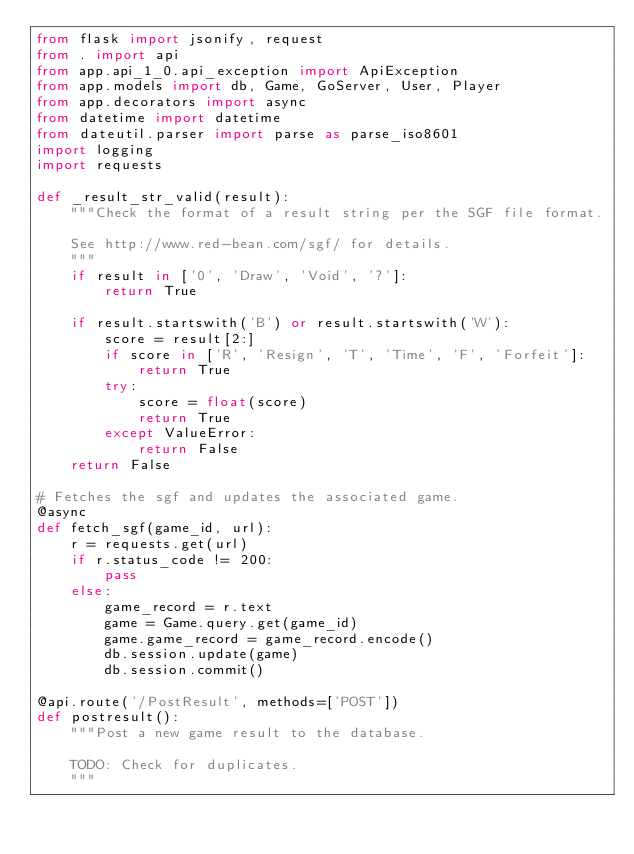<code> <loc_0><loc_0><loc_500><loc_500><_Python_>from flask import jsonify, request
from . import api
from app.api_1_0.api_exception import ApiException
from app.models import db, Game, GoServer, User, Player
from app.decorators import async
from datetime import datetime
from dateutil.parser import parse as parse_iso8601
import logging
import requests

def _result_str_valid(result):
    """Check the format of a result string per the SGF file format.

    See http://www.red-bean.com/sgf/ for details.
    """
    if result in ['0', 'Draw', 'Void', '?']:
        return True

    if result.startswith('B') or result.startswith('W'):
        score = result[2:]
        if score in ['R', 'Resign', 'T', 'Time', 'F', 'Forfeit']:
            return True
        try:
            score = float(score)
            return True
        except ValueError:
            return False
    return False

# Fetches the sgf and updates the associated game.
@async
def fetch_sgf(game_id, url):
    r = requests.get(url)
    if r.status_code != 200:
        pass
    else:
        game_record = r.text
        game = Game.query.get(game_id)
        game.game_record = game_record.encode()
        db.session.update(game)
        db.session.commit()

@api.route('/PostResult', methods=['POST'])
def postresult():
    """Post a new game result to the database.

    TODO: Check for duplicates.
    """</code> 